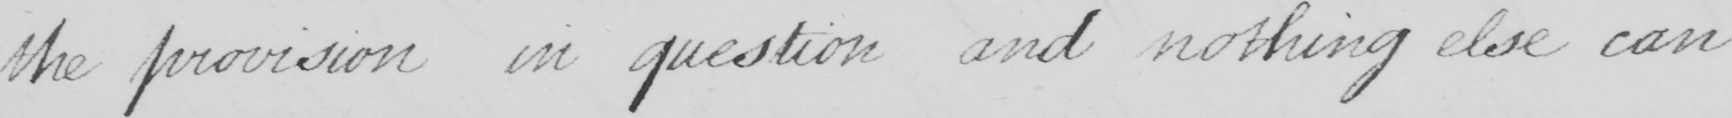Transcribe the text shown in this historical manuscript line. the provision in question and nothing else can 